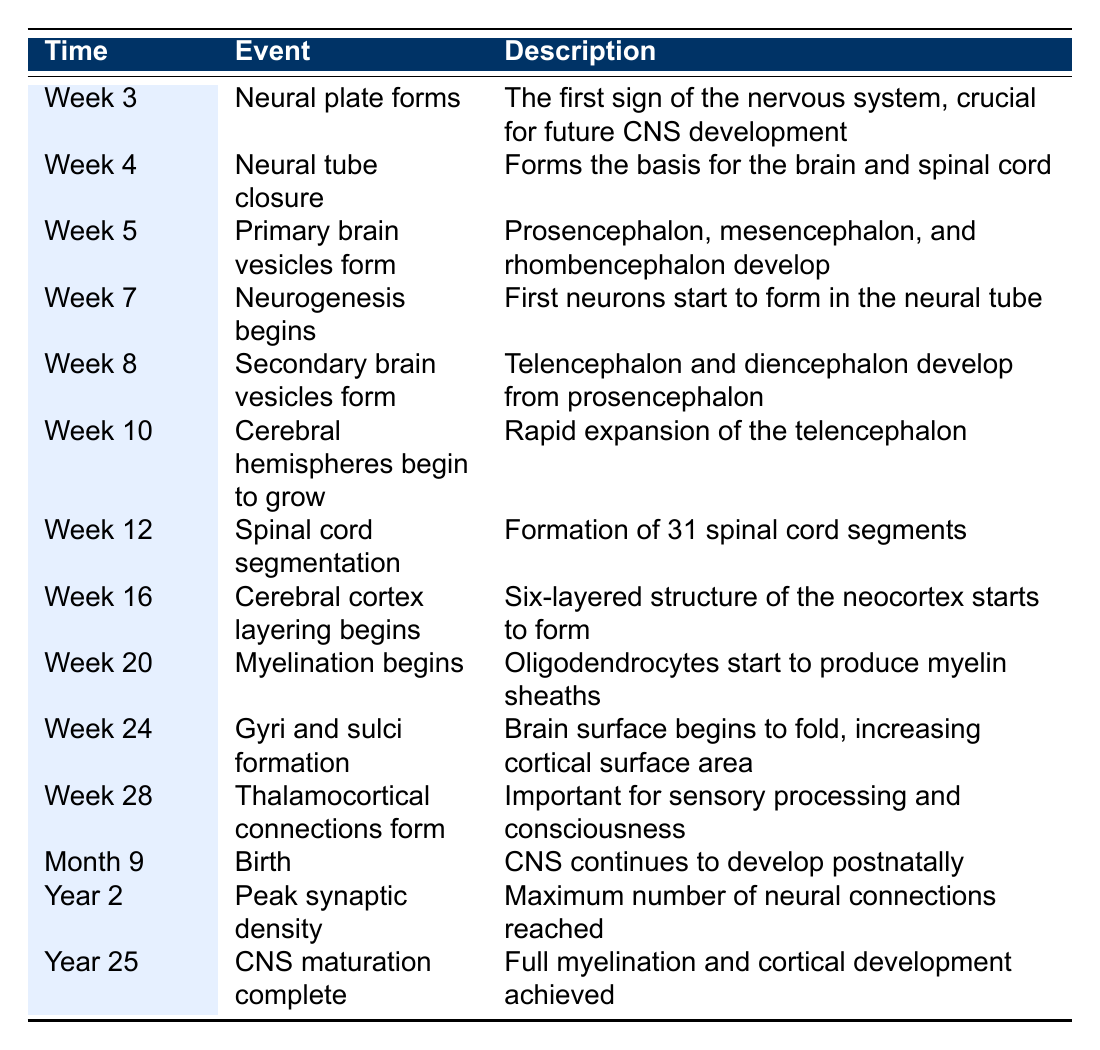What event occurs at week 4? According to the table, at week 4, the event is "Neural tube closure," which forms the basis for the brain and spinal cord.
Answer: Neural tube closure How many weeks before birth does myelination begin? Myelination begins at week 20, and birth occurs at month 9 (approximately week 36). The difference is 36 - 20 = 16 weeks.
Answer: 16 weeks Is 'Neurogenesis begins' the event that happens at week 7? Yes, the table indicates that the event at week 7 is "Neurogenesis begins."
Answer: Yes What is the first sign of the nervous system? The table states that the first sign of the nervous system is the formation of the "Neural plate" at week 3.
Answer: Neural plate Which neurological milestone occurs last in the timeline? The last event listed in the timeline is "CNS maturation complete" occurring at year 25.
Answer: CNS maturation complete What is the average time interval between the formation of primary brain vesicles and thalamocortical connections? Primary brain vesicles form at week 5 and thalamocortical connections form at week 28. The total interval is 28 - 5 = 23 weeks.
Answer: 23 weeks Does the spinal cord segmentation happen before or after week 16? The table states that spinal cord segmentation occurs at week 12, which is before week 16.
Answer: Before What key event happens at month 9? The event at month 9 is "Birth," and the description indicates that the CNS continues to develop postnatally.
Answer: Birth 